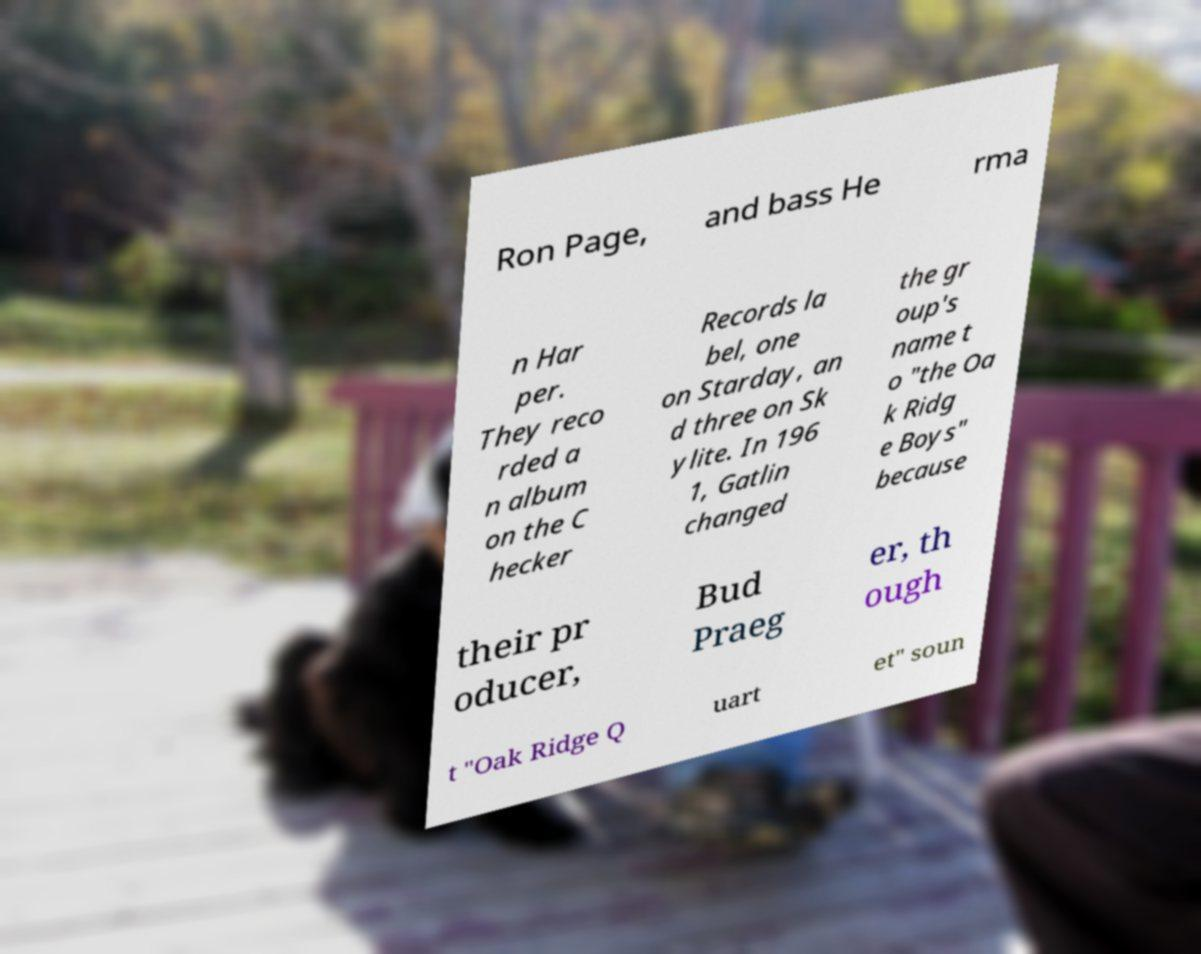There's text embedded in this image that I need extracted. Can you transcribe it verbatim? Ron Page, and bass He rma n Har per. They reco rded a n album on the C hecker Records la bel, one on Starday, an d three on Sk ylite. In 196 1, Gatlin changed the gr oup's name t o "the Oa k Ridg e Boys" because their pr oducer, Bud Praeg er, th ough t "Oak Ridge Q uart et" soun 